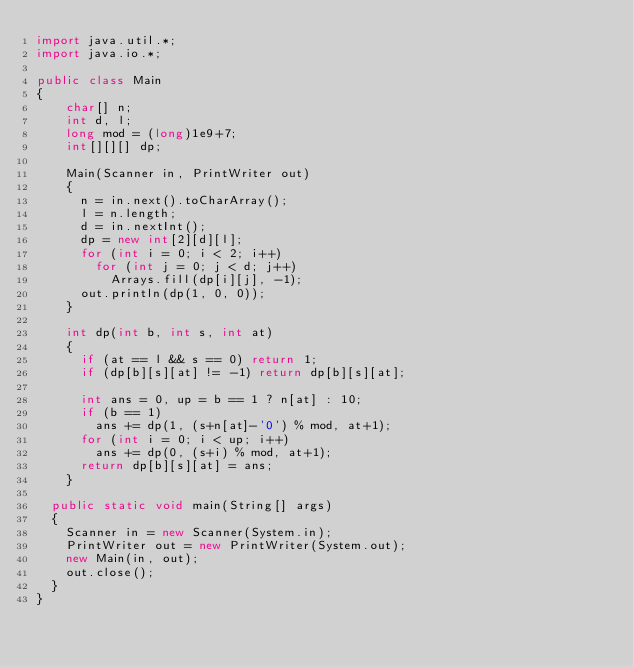<code> <loc_0><loc_0><loc_500><loc_500><_Java_>import java.util.*;
import java.io.*;

public class Main
{
  	char[] n;
  	int d, l;
  	long mod = (long)1e9+7;
  	int[][][] dp;
  
    Main(Scanner in, PrintWriter out)
    {
      n = in.next().toCharArray();
      l = n.length;
      d = in.nextInt();
      dp = new int[2][d][l];
      for (int i = 0; i < 2; i++)
        for (int j = 0; j < d; j++)
          Arrays.fill(dp[i][j], -1);
      out.println(dp(1, 0, 0));
    }
  
  	int dp(int b, int s, int at)
    {
      if (at == l && s == 0) return 1;
      if (dp[b][s][at] != -1) return dp[b][s][at];
      
      int ans = 0, up = b == 1 ? n[at] : 10;
      if (b == 1)
        ans += dp(1, (s+n[at]-'0') % mod, at+1);
      for (int i = 0; i < up; i++)
        ans += dp(0, (s+i) % mod, at+1);
      return dp[b][s][at] = ans;
    }
	
	public static void main(String[] args)
	{
		Scanner in = new Scanner(System.in);
		PrintWriter out = new PrintWriter(System.out);
		new	Main(in, out);
		out.close();
	} 
}</code> 